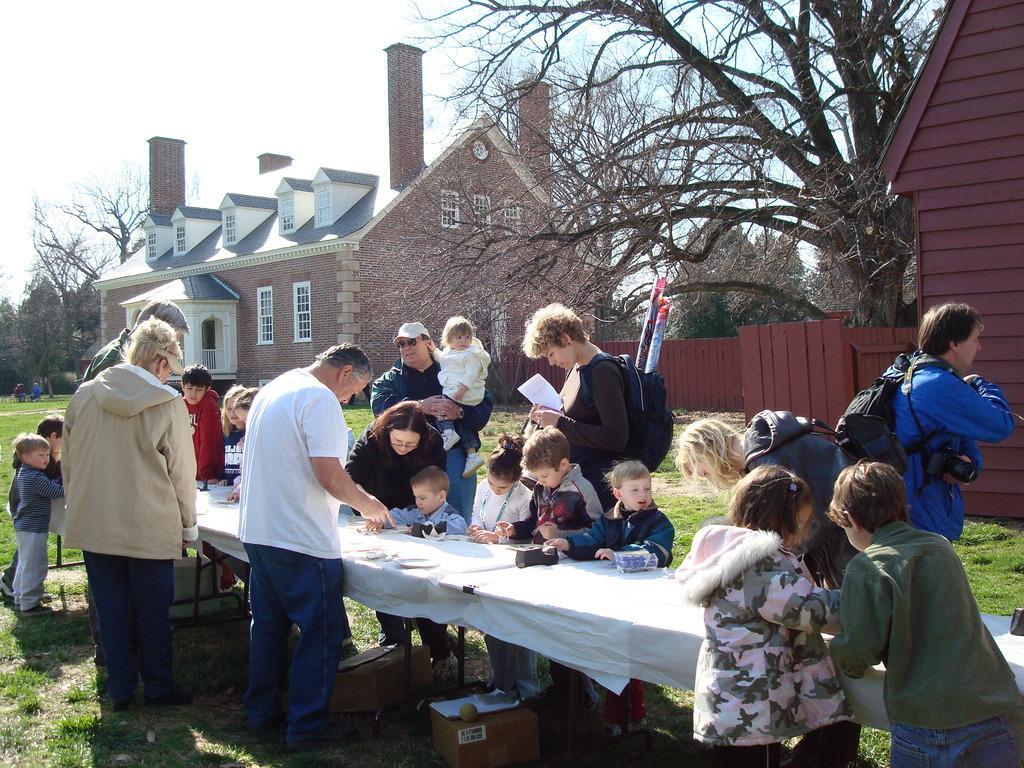Can you describe this image briefly? In this image we can see few persons are standing and sitting at the table and among them few persons are carrying bags on the shoulder and a person is holding kid in the hands and at the bottom we can see carton boxes and objects on the ground. In the background we can see objects, houses, trees, windows, few persons and clouds in the sky. 